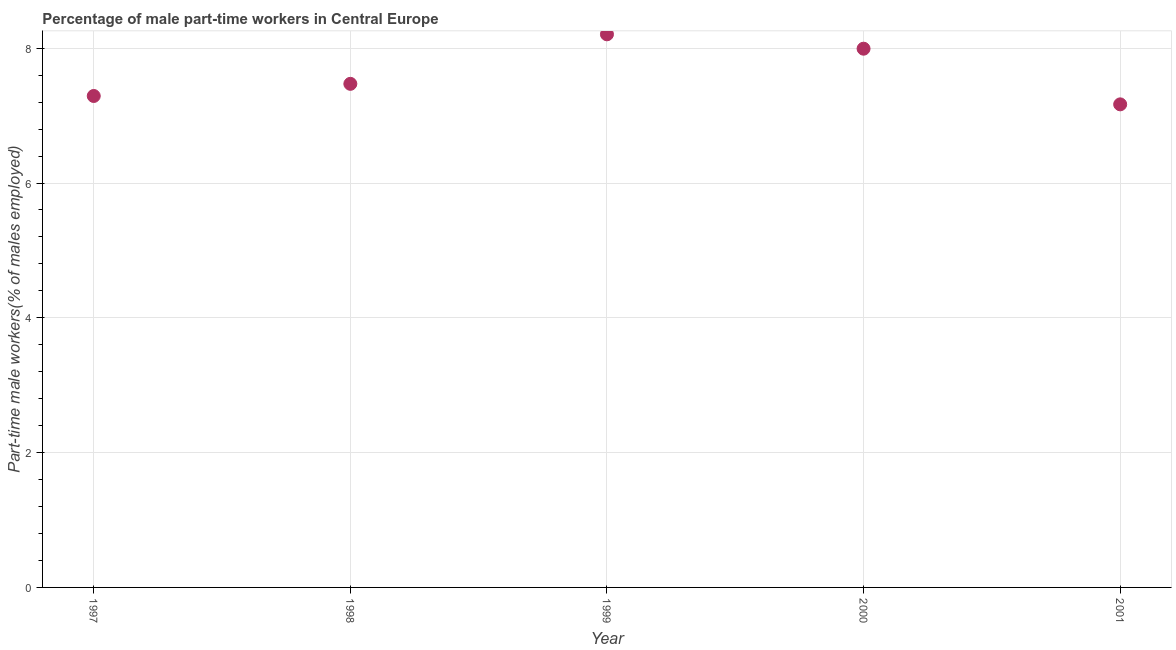What is the percentage of part-time male workers in 1997?
Make the answer very short. 7.29. Across all years, what is the maximum percentage of part-time male workers?
Your answer should be compact. 8.21. Across all years, what is the minimum percentage of part-time male workers?
Make the answer very short. 7.17. In which year was the percentage of part-time male workers maximum?
Provide a short and direct response. 1999. In which year was the percentage of part-time male workers minimum?
Your response must be concise. 2001. What is the sum of the percentage of part-time male workers?
Provide a succinct answer. 38.13. What is the difference between the percentage of part-time male workers in 1999 and 2000?
Provide a succinct answer. 0.21. What is the average percentage of part-time male workers per year?
Provide a succinct answer. 7.63. What is the median percentage of part-time male workers?
Provide a short and direct response. 7.47. In how many years, is the percentage of part-time male workers greater than 4.8 %?
Your response must be concise. 5. Do a majority of the years between 2001 and 1999 (inclusive) have percentage of part-time male workers greater than 4.4 %?
Offer a very short reply. No. What is the ratio of the percentage of part-time male workers in 1997 to that in 2001?
Provide a short and direct response. 1.02. What is the difference between the highest and the second highest percentage of part-time male workers?
Your answer should be very brief. 0.21. Is the sum of the percentage of part-time male workers in 1997 and 1998 greater than the maximum percentage of part-time male workers across all years?
Give a very brief answer. Yes. What is the difference between the highest and the lowest percentage of part-time male workers?
Give a very brief answer. 1.04. Does the percentage of part-time male workers monotonically increase over the years?
Your response must be concise. No. How many dotlines are there?
Offer a terse response. 1. Are the values on the major ticks of Y-axis written in scientific E-notation?
Keep it short and to the point. No. Does the graph contain any zero values?
Offer a terse response. No. What is the title of the graph?
Your answer should be compact. Percentage of male part-time workers in Central Europe. What is the label or title of the Y-axis?
Your answer should be compact. Part-time male workers(% of males employed). What is the Part-time male workers(% of males employed) in 1997?
Offer a terse response. 7.29. What is the Part-time male workers(% of males employed) in 1998?
Keep it short and to the point. 7.47. What is the Part-time male workers(% of males employed) in 1999?
Make the answer very short. 8.21. What is the Part-time male workers(% of males employed) in 2000?
Your answer should be compact. 7.99. What is the Part-time male workers(% of males employed) in 2001?
Offer a very short reply. 7.17. What is the difference between the Part-time male workers(% of males employed) in 1997 and 1998?
Your answer should be compact. -0.18. What is the difference between the Part-time male workers(% of males employed) in 1997 and 1999?
Your answer should be very brief. -0.91. What is the difference between the Part-time male workers(% of males employed) in 1997 and 2000?
Provide a succinct answer. -0.7. What is the difference between the Part-time male workers(% of males employed) in 1997 and 2001?
Offer a very short reply. 0.12. What is the difference between the Part-time male workers(% of males employed) in 1998 and 1999?
Make the answer very short. -0.73. What is the difference between the Part-time male workers(% of males employed) in 1998 and 2000?
Your answer should be compact. -0.52. What is the difference between the Part-time male workers(% of males employed) in 1998 and 2001?
Offer a terse response. 0.3. What is the difference between the Part-time male workers(% of males employed) in 1999 and 2000?
Provide a short and direct response. 0.21. What is the difference between the Part-time male workers(% of males employed) in 1999 and 2001?
Make the answer very short. 1.04. What is the difference between the Part-time male workers(% of males employed) in 2000 and 2001?
Provide a succinct answer. 0.83. What is the ratio of the Part-time male workers(% of males employed) in 1997 to that in 1998?
Your answer should be very brief. 0.98. What is the ratio of the Part-time male workers(% of males employed) in 1997 to that in 1999?
Your answer should be compact. 0.89. What is the ratio of the Part-time male workers(% of males employed) in 1997 to that in 2000?
Give a very brief answer. 0.91. What is the ratio of the Part-time male workers(% of males employed) in 1998 to that in 1999?
Make the answer very short. 0.91. What is the ratio of the Part-time male workers(% of males employed) in 1998 to that in 2000?
Your answer should be compact. 0.94. What is the ratio of the Part-time male workers(% of males employed) in 1998 to that in 2001?
Provide a succinct answer. 1.04. What is the ratio of the Part-time male workers(% of males employed) in 1999 to that in 2001?
Provide a succinct answer. 1.15. What is the ratio of the Part-time male workers(% of males employed) in 2000 to that in 2001?
Offer a very short reply. 1.11. 